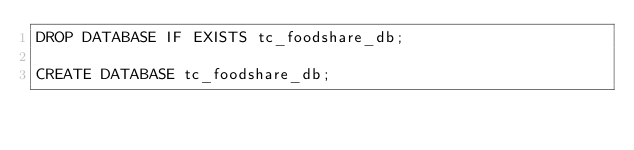Convert code to text. <code><loc_0><loc_0><loc_500><loc_500><_SQL_>DROP DATABASE IF EXISTS tc_foodshare_db;

CREATE DATABASE tc_foodshare_db;</code> 